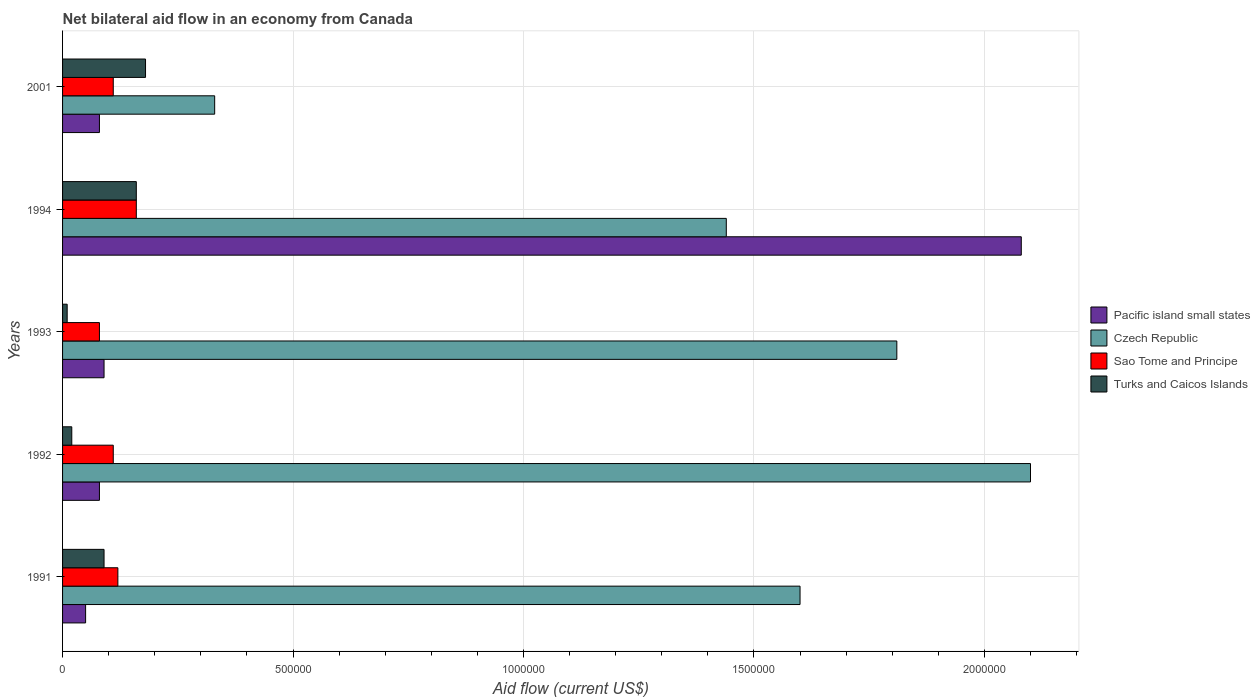How many groups of bars are there?
Your answer should be very brief. 5. Are the number of bars per tick equal to the number of legend labels?
Offer a very short reply. Yes. Are the number of bars on each tick of the Y-axis equal?
Offer a very short reply. Yes. How many bars are there on the 3rd tick from the top?
Offer a very short reply. 4. What is the net bilateral aid flow in Pacific island small states in 1993?
Ensure brevity in your answer.  9.00e+04. Across all years, what is the maximum net bilateral aid flow in Sao Tome and Principe?
Keep it short and to the point. 1.60e+05. Across all years, what is the minimum net bilateral aid flow in Turks and Caicos Islands?
Ensure brevity in your answer.  10000. What is the total net bilateral aid flow in Pacific island small states in the graph?
Give a very brief answer. 2.38e+06. What is the difference between the net bilateral aid flow in Turks and Caicos Islands in 1993 and that in 1994?
Your answer should be very brief. -1.50e+05. What is the difference between the net bilateral aid flow in Turks and Caicos Islands in 1994 and the net bilateral aid flow in Pacific island small states in 1991?
Provide a succinct answer. 1.10e+05. What is the average net bilateral aid flow in Czech Republic per year?
Ensure brevity in your answer.  1.46e+06. In how many years, is the net bilateral aid flow in Turks and Caicos Islands greater than 1900000 US$?
Your response must be concise. 0. What is the ratio of the net bilateral aid flow in Pacific island small states in 1991 to that in 2001?
Provide a short and direct response. 0.62. What is the difference between the highest and the second highest net bilateral aid flow in Czech Republic?
Provide a succinct answer. 2.90e+05. What is the difference between the highest and the lowest net bilateral aid flow in Pacific island small states?
Your answer should be compact. 2.03e+06. Is it the case that in every year, the sum of the net bilateral aid flow in Czech Republic and net bilateral aid flow in Pacific island small states is greater than the sum of net bilateral aid flow in Turks and Caicos Islands and net bilateral aid flow in Sao Tome and Principe?
Offer a very short reply. Yes. What does the 3rd bar from the top in 1993 represents?
Provide a short and direct response. Czech Republic. What does the 1st bar from the bottom in 2001 represents?
Offer a terse response. Pacific island small states. Does the graph contain grids?
Your answer should be compact. Yes. How are the legend labels stacked?
Ensure brevity in your answer.  Vertical. What is the title of the graph?
Keep it short and to the point. Net bilateral aid flow in an economy from Canada. Does "Togo" appear as one of the legend labels in the graph?
Give a very brief answer. No. What is the Aid flow (current US$) in Pacific island small states in 1991?
Your answer should be compact. 5.00e+04. What is the Aid flow (current US$) in Czech Republic in 1991?
Provide a succinct answer. 1.60e+06. What is the Aid flow (current US$) of Sao Tome and Principe in 1991?
Your response must be concise. 1.20e+05. What is the Aid flow (current US$) in Turks and Caicos Islands in 1991?
Keep it short and to the point. 9.00e+04. What is the Aid flow (current US$) in Pacific island small states in 1992?
Your response must be concise. 8.00e+04. What is the Aid flow (current US$) of Czech Republic in 1992?
Make the answer very short. 2.10e+06. What is the Aid flow (current US$) of Turks and Caicos Islands in 1992?
Provide a succinct answer. 2.00e+04. What is the Aid flow (current US$) in Pacific island small states in 1993?
Your response must be concise. 9.00e+04. What is the Aid flow (current US$) of Czech Republic in 1993?
Your answer should be very brief. 1.81e+06. What is the Aid flow (current US$) of Pacific island small states in 1994?
Make the answer very short. 2.08e+06. What is the Aid flow (current US$) of Czech Republic in 1994?
Provide a succinct answer. 1.44e+06. What is the Aid flow (current US$) in Sao Tome and Principe in 1994?
Provide a succinct answer. 1.60e+05. What is the Aid flow (current US$) of Czech Republic in 2001?
Provide a succinct answer. 3.30e+05. What is the Aid flow (current US$) in Sao Tome and Principe in 2001?
Offer a terse response. 1.10e+05. What is the Aid flow (current US$) in Turks and Caicos Islands in 2001?
Your answer should be very brief. 1.80e+05. Across all years, what is the maximum Aid flow (current US$) of Pacific island small states?
Offer a very short reply. 2.08e+06. Across all years, what is the maximum Aid flow (current US$) of Czech Republic?
Ensure brevity in your answer.  2.10e+06. Across all years, what is the maximum Aid flow (current US$) in Sao Tome and Principe?
Your answer should be compact. 1.60e+05. Across all years, what is the maximum Aid flow (current US$) of Turks and Caicos Islands?
Keep it short and to the point. 1.80e+05. Across all years, what is the minimum Aid flow (current US$) of Pacific island small states?
Your answer should be very brief. 5.00e+04. Across all years, what is the minimum Aid flow (current US$) in Czech Republic?
Give a very brief answer. 3.30e+05. What is the total Aid flow (current US$) of Pacific island small states in the graph?
Ensure brevity in your answer.  2.38e+06. What is the total Aid flow (current US$) in Czech Republic in the graph?
Provide a short and direct response. 7.28e+06. What is the total Aid flow (current US$) in Sao Tome and Principe in the graph?
Provide a succinct answer. 5.80e+05. What is the difference between the Aid flow (current US$) of Czech Republic in 1991 and that in 1992?
Provide a succinct answer. -5.00e+05. What is the difference between the Aid flow (current US$) of Sao Tome and Principe in 1991 and that in 1992?
Your answer should be compact. 10000. What is the difference between the Aid flow (current US$) in Czech Republic in 1991 and that in 1993?
Provide a short and direct response. -2.10e+05. What is the difference between the Aid flow (current US$) in Pacific island small states in 1991 and that in 1994?
Offer a terse response. -2.03e+06. What is the difference between the Aid flow (current US$) of Turks and Caicos Islands in 1991 and that in 1994?
Offer a terse response. -7.00e+04. What is the difference between the Aid flow (current US$) of Czech Republic in 1991 and that in 2001?
Make the answer very short. 1.27e+06. What is the difference between the Aid flow (current US$) in Sao Tome and Principe in 1992 and that in 1993?
Keep it short and to the point. 3.00e+04. What is the difference between the Aid flow (current US$) of Turks and Caicos Islands in 1992 and that in 1993?
Offer a very short reply. 10000. What is the difference between the Aid flow (current US$) of Pacific island small states in 1992 and that in 1994?
Your answer should be compact. -2.00e+06. What is the difference between the Aid flow (current US$) of Sao Tome and Principe in 1992 and that in 1994?
Ensure brevity in your answer.  -5.00e+04. What is the difference between the Aid flow (current US$) in Turks and Caicos Islands in 1992 and that in 1994?
Offer a very short reply. -1.40e+05. What is the difference between the Aid flow (current US$) of Pacific island small states in 1992 and that in 2001?
Offer a terse response. 0. What is the difference between the Aid flow (current US$) of Czech Republic in 1992 and that in 2001?
Offer a terse response. 1.77e+06. What is the difference between the Aid flow (current US$) in Turks and Caicos Islands in 1992 and that in 2001?
Your answer should be very brief. -1.60e+05. What is the difference between the Aid flow (current US$) of Pacific island small states in 1993 and that in 1994?
Offer a terse response. -1.99e+06. What is the difference between the Aid flow (current US$) of Czech Republic in 1993 and that in 2001?
Give a very brief answer. 1.48e+06. What is the difference between the Aid flow (current US$) of Turks and Caicos Islands in 1993 and that in 2001?
Provide a succinct answer. -1.70e+05. What is the difference between the Aid flow (current US$) in Czech Republic in 1994 and that in 2001?
Give a very brief answer. 1.11e+06. What is the difference between the Aid flow (current US$) of Sao Tome and Principe in 1994 and that in 2001?
Your response must be concise. 5.00e+04. What is the difference between the Aid flow (current US$) of Turks and Caicos Islands in 1994 and that in 2001?
Give a very brief answer. -2.00e+04. What is the difference between the Aid flow (current US$) in Pacific island small states in 1991 and the Aid flow (current US$) in Czech Republic in 1992?
Keep it short and to the point. -2.05e+06. What is the difference between the Aid flow (current US$) of Pacific island small states in 1991 and the Aid flow (current US$) of Sao Tome and Principe in 1992?
Keep it short and to the point. -6.00e+04. What is the difference between the Aid flow (current US$) of Pacific island small states in 1991 and the Aid flow (current US$) of Turks and Caicos Islands in 1992?
Make the answer very short. 3.00e+04. What is the difference between the Aid flow (current US$) in Czech Republic in 1991 and the Aid flow (current US$) in Sao Tome and Principe in 1992?
Offer a terse response. 1.49e+06. What is the difference between the Aid flow (current US$) in Czech Republic in 1991 and the Aid flow (current US$) in Turks and Caicos Islands in 1992?
Your response must be concise. 1.58e+06. What is the difference between the Aid flow (current US$) in Sao Tome and Principe in 1991 and the Aid flow (current US$) in Turks and Caicos Islands in 1992?
Give a very brief answer. 1.00e+05. What is the difference between the Aid flow (current US$) of Pacific island small states in 1991 and the Aid flow (current US$) of Czech Republic in 1993?
Ensure brevity in your answer.  -1.76e+06. What is the difference between the Aid flow (current US$) of Pacific island small states in 1991 and the Aid flow (current US$) of Turks and Caicos Islands in 1993?
Your answer should be compact. 4.00e+04. What is the difference between the Aid flow (current US$) in Czech Republic in 1991 and the Aid flow (current US$) in Sao Tome and Principe in 1993?
Provide a succinct answer. 1.52e+06. What is the difference between the Aid flow (current US$) of Czech Republic in 1991 and the Aid flow (current US$) of Turks and Caicos Islands in 1993?
Offer a terse response. 1.59e+06. What is the difference between the Aid flow (current US$) in Pacific island small states in 1991 and the Aid flow (current US$) in Czech Republic in 1994?
Your response must be concise. -1.39e+06. What is the difference between the Aid flow (current US$) of Pacific island small states in 1991 and the Aid flow (current US$) of Sao Tome and Principe in 1994?
Offer a very short reply. -1.10e+05. What is the difference between the Aid flow (current US$) in Czech Republic in 1991 and the Aid flow (current US$) in Sao Tome and Principe in 1994?
Keep it short and to the point. 1.44e+06. What is the difference between the Aid flow (current US$) in Czech Republic in 1991 and the Aid flow (current US$) in Turks and Caicos Islands in 1994?
Ensure brevity in your answer.  1.44e+06. What is the difference between the Aid flow (current US$) in Sao Tome and Principe in 1991 and the Aid flow (current US$) in Turks and Caicos Islands in 1994?
Provide a succinct answer. -4.00e+04. What is the difference between the Aid flow (current US$) of Pacific island small states in 1991 and the Aid flow (current US$) of Czech Republic in 2001?
Give a very brief answer. -2.80e+05. What is the difference between the Aid flow (current US$) in Czech Republic in 1991 and the Aid flow (current US$) in Sao Tome and Principe in 2001?
Your answer should be compact. 1.49e+06. What is the difference between the Aid flow (current US$) of Czech Republic in 1991 and the Aid flow (current US$) of Turks and Caicos Islands in 2001?
Give a very brief answer. 1.42e+06. What is the difference between the Aid flow (current US$) in Sao Tome and Principe in 1991 and the Aid flow (current US$) in Turks and Caicos Islands in 2001?
Keep it short and to the point. -6.00e+04. What is the difference between the Aid flow (current US$) of Pacific island small states in 1992 and the Aid flow (current US$) of Czech Republic in 1993?
Ensure brevity in your answer.  -1.73e+06. What is the difference between the Aid flow (current US$) in Pacific island small states in 1992 and the Aid flow (current US$) in Sao Tome and Principe in 1993?
Provide a short and direct response. 0. What is the difference between the Aid flow (current US$) of Pacific island small states in 1992 and the Aid flow (current US$) of Turks and Caicos Islands in 1993?
Ensure brevity in your answer.  7.00e+04. What is the difference between the Aid flow (current US$) of Czech Republic in 1992 and the Aid flow (current US$) of Sao Tome and Principe in 1993?
Your answer should be compact. 2.02e+06. What is the difference between the Aid flow (current US$) in Czech Republic in 1992 and the Aid flow (current US$) in Turks and Caicos Islands in 1993?
Ensure brevity in your answer.  2.09e+06. What is the difference between the Aid flow (current US$) of Pacific island small states in 1992 and the Aid flow (current US$) of Czech Republic in 1994?
Your response must be concise. -1.36e+06. What is the difference between the Aid flow (current US$) of Pacific island small states in 1992 and the Aid flow (current US$) of Sao Tome and Principe in 1994?
Keep it short and to the point. -8.00e+04. What is the difference between the Aid flow (current US$) in Pacific island small states in 1992 and the Aid flow (current US$) in Turks and Caicos Islands in 1994?
Give a very brief answer. -8.00e+04. What is the difference between the Aid flow (current US$) in Czech Republic in 1992 and the Aid flow (current US$) in Sao Tome and Principe in 1994?
Your response must be concise. 1.94e+06. What is the difference between the Aid flow (current US$) of Czech Republic in 1992 and the Aid flow (current US$) of Turks and Caicos Islands in 1994?
Offer a terse response. 1.94e+06. What is the difference between the Aid flow (current US$) in Pacific island small states in 1992 and the Aid flow (current US$) in Czech Republic in 2001?
Make the answer very short. -2.50e+05. What is the difference between the Aid flow (current US$) of Pacific island small states in 1992 and the Aid flow (current US$) of Turks and Caicos Islands in 2001?
Your response must be concise. -1.00e+05. What is the difference between the Aid flow (current US$) in Czech Republic in 1992 and the Aid flow (current US$) in Sao Tome and Principe in 2001?
Give a very brief answer. 1.99e+06. What is the difference between the Aid flow (current US$) of Czech Republic in 1992 and the Aid flow (current US$) of Turks and Caicos Islands in 2001?
Provide a succinct answer. 1.92e+06. What is the difference between the Aid flow (current US$) of Pacific island small states in 1993 and the Aid flow (current US$) of Czech Republic in 1994?
Offer a very short reply. -1.35e+06. What is the difference between the Aid flow (current US$) of Czech Republic in 1993 and the Aid flow (current US$) of Sao Tome and Principe in 1994?
Your answer should be very brief. 1.65e+06. What is the difference between the Aid flow (current US$) in Czech Republic in 1993 and the Aid flow (current US$) in Turks and Caicos Islands in 1994?
Keep it short and to the point. 1.65e+06. What is the difference between the Aid flow (current US$) in Sao Tome and Principe in 1993 and the Aid flow (current US$) in Turks and Caicos Islands in 1994?
Your response must be concise. -8.00e+04. What is the difference between the Aid flow (current US$) in Pacific island small states in 1993 and the Aid flow (current US$) in Sao Tome and Principe in 2001?
Offer a very short reply. -2.00e+04. What is the difference between the Aid flow (current US$) in Czech Republic in 1993 and the Aid flow (current US$) in Sao Tome and Principe in 2001?
Provide a succinct answer. 1.70e+06. What is the difference between the Aid flow (current US$) in Czech Republic in 1993 and the Aid flow (current US$) in Turks and Caicos Islands in 2001?
Ensure brevity in your answer.  1.63e+06. What is the difference between the Aid flow (current US$) of Pacific island small states in 1994 and the Aid flow (current US$) of Czech Republic in 2001?
Provide a succinct answer. 1.75e+06. What is the difference between the Aid flow (current US$) in Pacific island small states in 1994 and the Aid flow (current US$) in Sao Tome and Principe in 2001?
Give a very brief answer. 1.97e+06. What is the difference between the Aid flow (current US$) in Pacific island small states in 1994 and the Aid flow (current US$) in Turks and Caicos Islands in 2001?
Your answer should be very brief. 1.90e+06. What is the difference between the Aid flow (current US$) in Czech Republic in 1994 and the Aid flow (current US$) in Sao Tome and Principe in 2001?
Offer a very short reply. 1.33e+06. What is the difference between the Aid flow (current US$) in Czech Republic in 1994 and the Aid flow (current US$) in Turks and Caicos Islands in 2001?
Your response must be concise. 1.26e+06. What is the average Aid flow (current US$) of Pacific island small states per year?
Keep it short and to the point. 4.76e+05. What is the average Aid flow (current US$) in Czech Republic per year?
Give a very brief answer. 1.46e+06. What is the average Aid flow (current US$) in Sao Tome and Principe per year?
Offer a terse response. 1.16e+05. What is the average Aid flow (current US$) in Turks and Caicos Islands per year?
Your answer should be very brief. 9.20e+04. In the year 1991, what is the difference between the Aid flow (current US$) in Pacific island small states and Aid flow (current US$) in Czech Republic?
Keep it short and to the point. -1.55e+06. In the year 1991, what is the difference between the Aid flow (current US$) of Pacific island small states and Aid flow (current US$) of Turks and Caicos Islands?
Ensure brevity in your answer.  -4.00e+04. In the year 1991, what is the difference between the Aid flow (current US$) of Czech Republic and Aid flow (current US$) of Sao Tome and Principe?
Make the answer very short. 1.48e+06. In the year 1991, what is the difference between the Aid flow (current US$) of Czech Republic and Aid flow (current US$) of Turks and Caicos Islands?
Your response must be concise. 1.51e+06. In the year 1992, what is the difference between the Aid flow (current US$) of Pacific island small states and Aid flow (current US$) of Czech Republic?
Provide a succinct answer. -2.02e+06. In the year 1992, what is the difference between the Aid flow (current US$) of Pacific island small states and Aid flow (current US$) of Turks and Caicos Islands?
Keep it short and to the point. 6.00e+04. In the year 1992, what is the difference between the Aid flow (current US$) in Czech Republic and Aid flow (current US$) in Sao Tome and Principe?
Your answer should be very brief. 1.99e+06. In the year 1992, what is the difference between the Aid flow (current US$) of Czech Republic and Aid flow (current US$) of Turks and Caicos Islands?
Keep it short and to the point. 2.08e+06. In the year 1992, what is the difference between the Aid flow (current US$) of Sao Tome and Principe and Aid flow (current US$) of Turks and Caicos Islands?
Your response must be concise. 9.00e+04. In the year 1993, what is the difference between the Aid flow (current US$) in Pacific island small states and Aid flow (current US$) in Czech Republic?
Give a very brief answer. -1.72e+06. In the year 1993, what is the difference between the Aid flow (current US$) of Pacific island small states and Aid flow (current US$) of Sao Tome and Principe?
Your answer should be very brief. 10000. In the year 1993, what is the difference between the Aid flow (current US$) of Pacific island small states and Aid flow (current US$) of Turks and Caicos Islands?
Give a very brief answer. 8.00e+04. In the year 1993, what is the difference between the Aid flow (current US$) in Czech Republic and Aid flow (current US$) in Sao Tome and Principe?
Your answer should be very brief. 1.73e+06. In the year 1993, what is the difference between the Aid flow (current US$) of Czech Republic and Aid flow (current US$) of Turks and Caicos Islands?
Make the answer very short. 1.80e+06. In the year 1993, what is the difference between the Aid flow (current US$) in Sao Tome and Principe and Aid flow (current US$) in Turks and Caicos Islands?
Provide a succinct answer. 7.00e+04. In the year 1994, what is the difference between the Aid flow (current US$) of Pacific island small states and Aid flow (current US$) of Czech Republic?
Make the answer very short. 6.40e+05. In the year 1994, what is the difference between the Aid flow (current US$) in Pacific island small states and Aid flow (current US$) in Sao Tome and Principe?
Give a very brief answer. 1.92e+06. In the year 1994, what is the difference between the Aid flow (current US$) in Pacific island small states and Aid flow (current US$) in Turks and Caicos Islands?
Offer a terse response. 1.92e+06. In the year 1994, what is the difference between the Aid flow (current US$) in Czech Republic and Aid flow (current US$) in Sao Tome and Principe?
Your answer should be compact. 1.28e+06. In the year 1994, what is the difference between the Aid flow (current US$) of Czech Republic and Aid flow (current US$) of Turks and Caicos Islands?
Your answer should be compact. 1.28e+06. In the year 2001, what is the difference between the Aid flow (current US$) in Pacific island small states and Aid flow (current US$) in Czech Republic?
Make the answer very short. -2.50e+05. In the year 2001, what is the difference between the Aid flow (current US$) in Pacific island small states and Aid flow (current US$) in Sao Tome and Principe?
Keep it short and to the point. -3.00e+04. In the year 2001, what is the difference between the Aid flow (current US$) of Czech Republic and Aid flow (current US$) of Sao Tome and Principe?
Your answer should be compact. 2.20e+05. In the year 2001, what is the difference between the Aid flow (current US$) in Czech Republic and Aid flow (current US$) in Turks and Caicos Islands?
Offer a terse response. 1.50e+05. In the year 2001, what is the difference between the Aid flow (current US$) in Sao Tome and Principe and Aid flow (current US$) in Turks and Caicos Islands?
Your response must be concise. -7.00e+04. What is the ratio of the Aid flow (current US$) in Pacific island small states in 1991 to that in 1992?
Offer a very short reply. 0.62. What is the ratio of the Aid flow (current US$) of Czech Republic in 1991 to that in 1992?
Keep it short and to the point. 0.76. What is the ratio of the Aid flow (current US$) of Pacific island small states in 1991 to that in 1993?
Give a very brief answer. 0.56. What is the ratio of the Aid flow (current US$) of Czech Republic in 1991 to that in 1993?
Offer a very short reply. 0.88. What is the ratio of the Aid flow (current US$) in Sao Tome and Principe in 1991 to that in 1993?
Ensure brevity in your answer.  1.5. What is the ratio of the Aid flow (current US$) of Turks and Caicos Islands in 1991 to that in 1993?
Your answer should be compact. 9. What is the ratio of the Aid flow (current US$) of Pacific island small states in 1991 to that in 1994?
Make the answer very short. 0.02. What is the ratio of the Aid flow (current US$) in Turks and Caicos Islands in 1991 to that in 1994?
Your answer should be compact. 0.56. What is the ratio of the Aid flow (current US$) in Pacific island small states in 1991 to that in 2001?
Your response must be concise. 0.62. What is the ratio of the Aid flow (current US$) in Czech Republic in 1991 to that in 2001?
Ensure brevity in your answer.  4.85. What is the ratio of the Aid flow (current US$) in Sao Tome and Principe in 1991 to that in 2001?
Keep it short and to the point. 1.09. What is the ratio of the Aid flow (current US$) of Czech Republic in 1992 to that in 1993?
Keep it short and to the point. 1.16. What is the ratio of the Aid flow (current US$) in Sao Tome and Principe in 1992 to that in 1993?
Provide a short and direct response. 1.38. What is the ratio of the Aid flow (current US$) in Turks and Caicos Islands in 1992 to that in 1993?
Your answer should be compact. 2. What is the ratio of the Aid flow (current US$) of Pacific island small states in 1992 to that in 1994?
Your answer should be very brief. 0.04. What is the ratio of the Aid flow (current US$) of Czech Republic in 1992 to that in 1994?
Give a very brief answer. 1.46. What is the ratio of the Aid flow (current US$) in Sao Tome and Principe in 1992 to that in 1994?
Make the answer very short. 0.69. What is the ratio of the Aid flow (current US$) in Czech Republic in 1992 to that in 2001?
Offer a very short reply. 6.36. What is the ratio of the Aid flow (current US$) of Pacific island small states in 1993 to that in 1994?
Provide a short and direct response. 0.04. What is the ratio of the Aid flow (current US$) in Czech Republic in 1993 to that in 1994?
Offer a terse response. 1.26. What is the ratio of the Aid flow (current US$) of Turks and Caicos Islands in 1993 to that in 1994?
Provide a succinct answer. 0.06. What is the ratio of the Aid flow (current US$) of Czech Republic in 1993 to that in 2001?
Provide a succinct answer. 5.48. What is the ratio of the Aid flow (current US$) of Sao Tome and Principe in 1993 to that in 2001?
Make the answer very short. 0.73. What is the ratio of the Aid flow (current US$) of Turks and Caicos Islands in 1993 to that in 2001?
Ensure brevity in your answer.  0.06. What is the ratio of the Aid flow (current US$) in Czech Republic in 1994 to that in 2001?
Offer a very short reply. 4.36. What is the ratio of the Aid flow (current US$) of Sao Tome and Principe in 1994 to that in 2001?
Ensure brevity in your answer.  1.45. What is the ratio of the Aid flow (current US$) of Turks and Caicos Islands in 1994 to that in 2001?
Your answer should be very brief. 0.89. What is the difference between the highest and the second highest Aid flow (current US$) in Pacific island small states?
Offer a very short reply. 1.99e+06. What is the difference between the highest and the second highest Aid flow (current US$) of Sao Tome and Principe?
Offer a terse response. 4.00e+04. What is the difference between the highest and the second highest Aid flow (current US$) of Turks and Caicos Islands?
Provide a short and direct response. 2.00e+04. What is the difference between the highest and the lowest Aid flow (current US$) in Pacific island small states?
Keep it short and to the point. 2.03e+06. What is the difference between the highest and the lowest Aid flow (current US$) in Czech Republic?
Your answer should be very brief. 1.77e+06. What is the difference between the highest and the lowest Aid flow (current US$) of Sao Tome and Principe?
Offer a very short reply. 8.00e+04. 